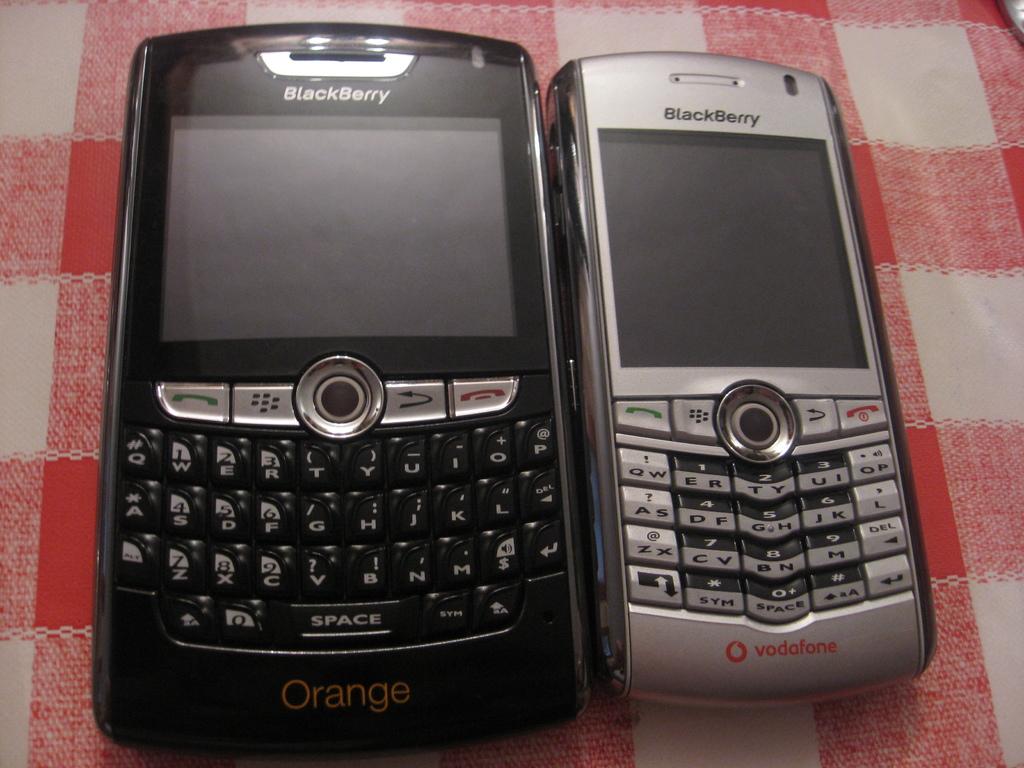What type of phone is this?
Keep it short and to the point. Blackberry. What is the color written on the bottom of the black phone?
Make the answer very short. Orange. 